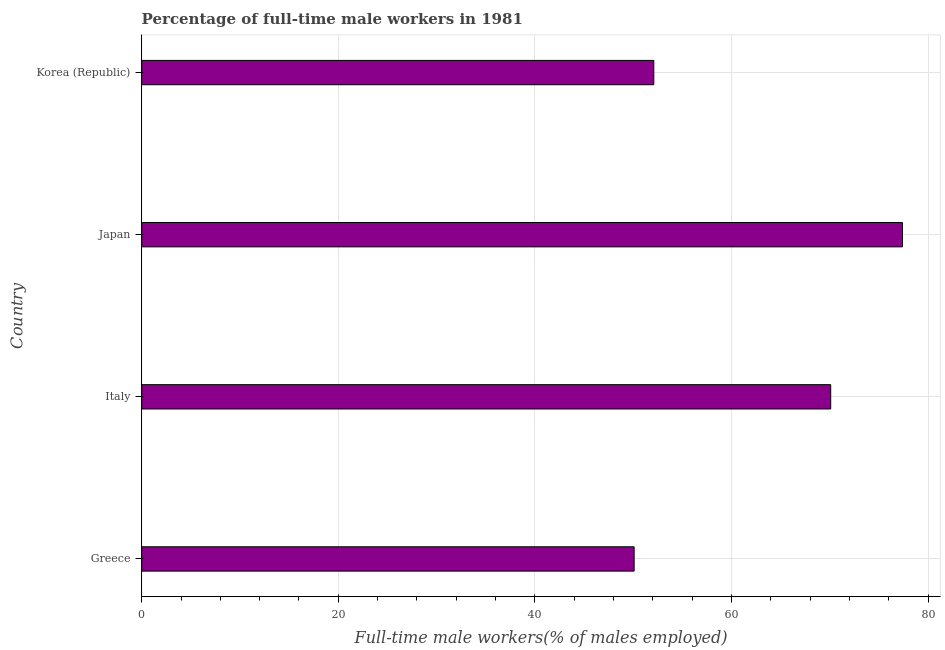Does the graph contain grids?
Make the answer very short. Yes. What is the title of the graph?
Keep it short and to the point. Percentage of full-time male workers in 1981. What is the label or title of the X-axis?
Give a very brief answer. Full-time male workers(% of males employed). What is the label or title of the Y-axis?
Provide a succinct answer. Country. What is the percentage of full-time male workers in Japan?
Provide a succinct answer. 77.4. Across all countries, what is the maximum percentage of full-time male workers?
Your answer should be very brief. 77.4. Across all countries, what is the minimum percentage of full-time male workers?
Your response must be concise. 50.1. What is the sum of the percentage of full-time male workers?
Your answer should be compact. 249.7. What is the difference between the percentage of full-time male workers in Greece and Japan?
Offer a very short reply. -27.3. What is the average percentage of full-time male workers per country?
Make the answer very short. 62.42. What is the median percentage of full-time male workers?
Ensure brevity in your answer.  61.1. What is the ratio of the percentage of full-time male workers in Japan to that in Korea (Republic)?
Make the answer very short. 1.49. Is the difference between the percentage of full-time male workers in Greece and Italy greater than the difference between any two countries?
Provide a short and direct response. No. What is the difference between the highest and the second highest percentage of full-time male workers?
Offer a very short reply. 7.3. Is the sum of the percentage of full-time male workers in Italy and Korea (Republic) greater than the maximum percentage of full-time male workers across all countries?
Provide a short and direct response. Yes. What is the difference between the highest and the lowest percentage of full-time male workers?
Keep it short and to the point. 27.3. In how many countries, is the percentage of full-time male workers greater than the average percentage of full-time male workers taken over all countries?
Offer a terse response. 2. Are all the bars in the graph horizontal?
Provide a short and direct response. Yes. What is the difference between two consecutive major ticks on the X-axis?
Offer a very short reply. 20. Are the values on the major ticks of X-axis written in scientific E-notation?
Your answer should be compact. No. What is the Full-time male workers(% of males employed) of Greece?
Offer a terse response. 50.1. What is the Full-time male workers(% of males employed) in Italy?
Offer a very short reply. 70.1. What is the Full-time male workers(% of males employed) in Japan?
Give a very brief answer. 77.4. What is the Full-time male workers(% of males employed) of Korea (Republic)?
Make the answer very short. 52.1. What is the difference between the Full-time male workers(% of males employed) in Greece and Japan?
Provide a short and direct response. -27.3. What is the difference between the Full-time male workers(% of males employed) in Japan and Korea (Republic)?
Provide a succinct answer. 25.3. What is the ratio of the Full-time male workers(% of males employed) in Greece to that in Italy?
Make the answer very short. 0.71. What is the ratio of the Full-time male workers(% of males employed) in Greece to that in Japan?
Keep it short and to the point. 0.65. What is the ratio of the Full-time male workers(% of males employed) in Italy to that in Japan?
Your response must be concise. 0.91. What is the ratio of the Full-time male workers(% of males employed) in Italy to that in Korea (Republic)?
Your answer should be very brief. 1.34. What is the ratio of the Full-time male workers(% of males employed) in Japan to that in Korea (Republic)?
Offer a very short reply. 1.49. 